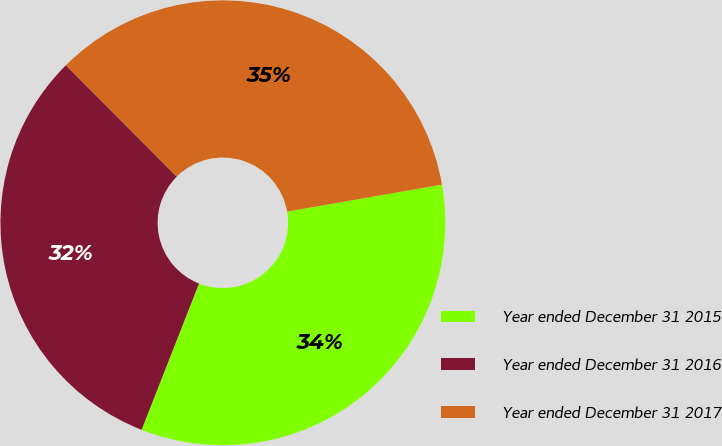Convert chart. <chart><loc_0><loc_0><loc_500><loc_500><pie_chart><fcel>Year ended December 31 2015<fcel>Year ended December 31 2016<fcel>Year ended December 31 2017<nl><fcel>33.7%<fcel>31.57%<fcel>34.73%<nl></chart> 